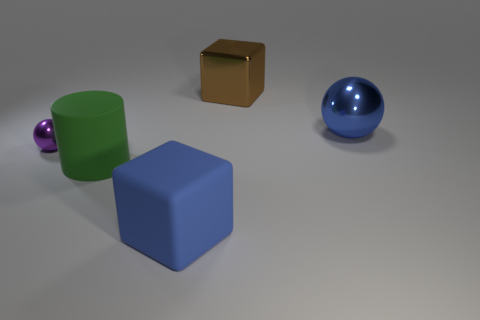What is the material of the green object that is the same size as the brown metallic object?
Make the answer very short. Rubber. Does the big brown object have the same shape as the purple thing?
Offer a very short reply. No. What number of objects are cubes or objects that are behind the big blue rubber cube?
Provide a succinct answer. 5. There is a sphere that is the same color as the big matte block; what is it made of?
Ensure brevity in your answer.  Metal. There is a ball left of the rubber cube; is it the same size as the blue block?
Provide a succinct answer. No. What number of brown objects are to the right of the big block that is to the left of the big cube that is behind the large blue metal sphere?
Give a very brief answer. 1. How many purple things are either tiny spheres or tiny cubes?
Offer a very short reply. 1. There is a object that is the same material as the cylinder; what is its color?
Offer a terse response. Blue. Are there any other things that are the same size as the rubber block?
Make the answer very short. Yes. What number of small things are blue metal things or brown blocks?
Your answer should be very brief. 0. 